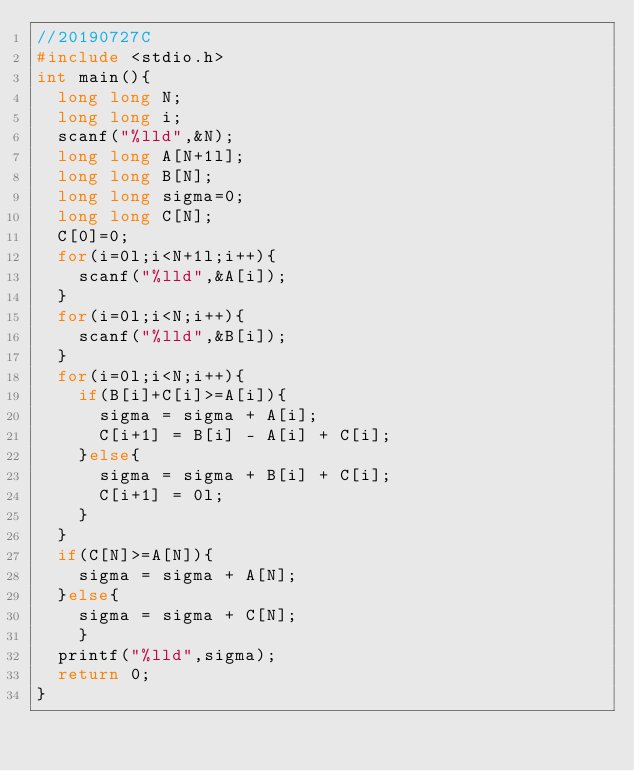Convert code to text. <code><loc_0><loc_0><loc_500><loc_500><_C_>//20190727C
#include <stdio.h>
int main(){
	long long N;
	long long i;
	scanf("%lld",&N);
	long long A[N+1l];
	long long B[N];
	long long sigma=0;
	long long C[N];
	C[0]=0;
	for(i=0l;i<N+1l;i++){
		scanf("%lld",&A[i]);
	}
	for(i=0l;i<N;i++){
		scanf("%lld",&B[i]);
	}
	for(i=0l;i<N;i++){
		if(B[i]+C[i]>=A[i]){
			sigma = sigma + A[i];
			C[i+1] = B[i] - A[i] + C[i];
		}else{
			sigma = sigma + B[i] + C[i];
			C[i+1] = 0l;
		}
	}
	if(C[N]>=A[N]){
		sigma = sigma + A[N];
	}else{
		sigma = sigma + C[N];
		}
	printf("%lld",sigma);
	return 0;
}</code> 